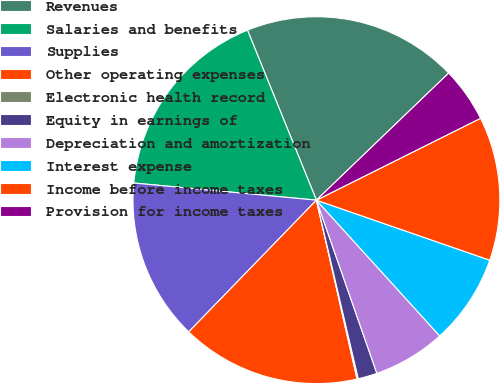Convert chart to OTSL. <chart><loc_0><loc_0><loc_500><loc_500><pie_chart><fcel>Revenues<fcel>Salaries and benefits<fcel>Supplies<fcel>Other operating expenses<fcel>Electronic health record<fcel>Equity in earnings of<fcel>Depreciation and amortization<fcel>Interest expense<fcel>Income before income taxes<fcel>Provision for income taxes<nl><fcel>18.95%<fcel>17.38%<fcel>14.24%<fcel>15.81%<fcel>0.11%<fcel>1.68%<fcel>6.39%<fcel>7.96%<fcel>12.67%<fcel>4.82%<nl></chart> 